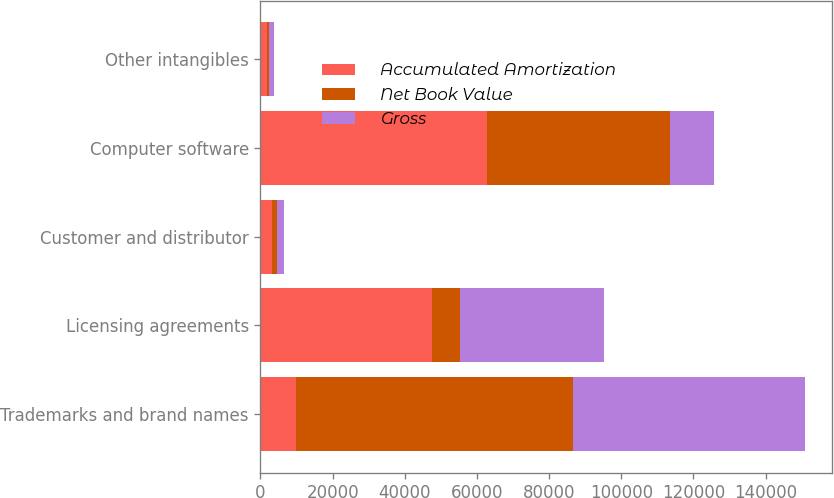Convert chart. <chart><loc_0><loc_0><loc_500><loc_500><stacked_bar_chart><ecel><fcel>Trademarks and brand names<fcel>Licensing agreements<fcel>Customer and distributor<fcel>Computer software<fcel>Other intangibles<nl><fcel>Accumulated Amortization<fcel>9938<fcel>47600<fcel>3327<fcel>62820<fcel>1921<nl><fcel>Net Book Value<fcel>76606<fcel>7612<fcel>1300<fcel>50556<fcel>335<nl><fcel>Gross<fcel>64249<fcel>39988<fcel>2027<fcel>12264<fcel>1586<nl></chart> 